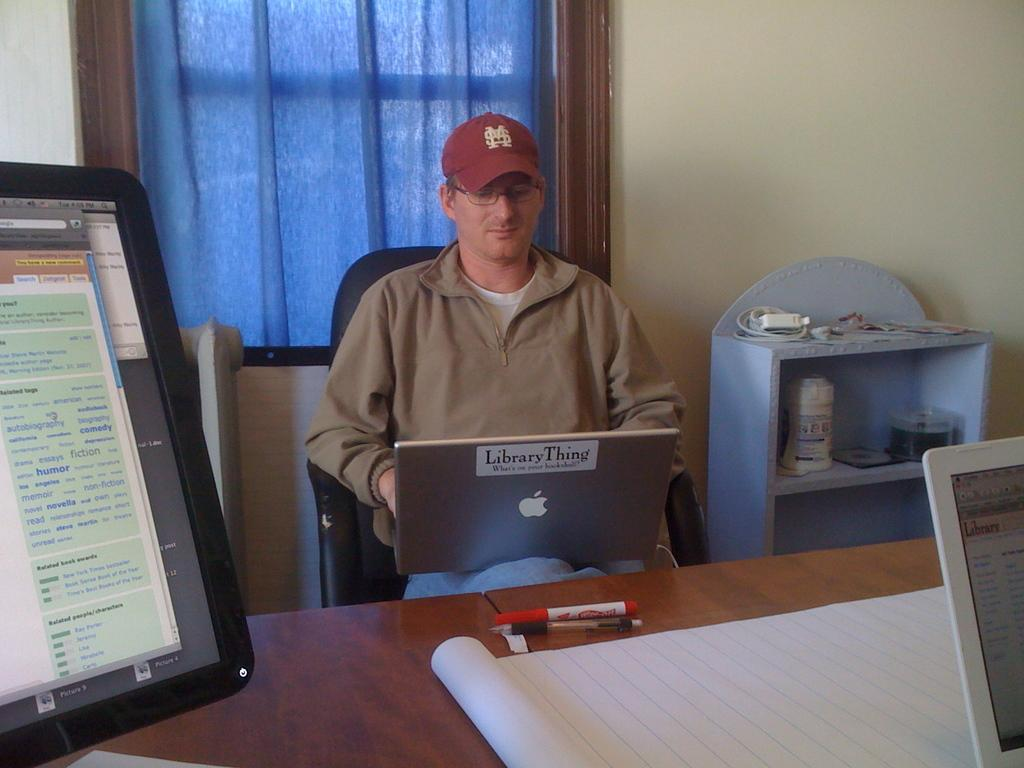<image>
Share a concise interpretation of the image provided. A man is typing on a laptop with a library thing sticker on the back. 